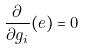<formula> <loc_0><loc_0><loc_500><loc_500>\frac { \partial } { \partial g _ { i } } ( e ) = 0</formula> 